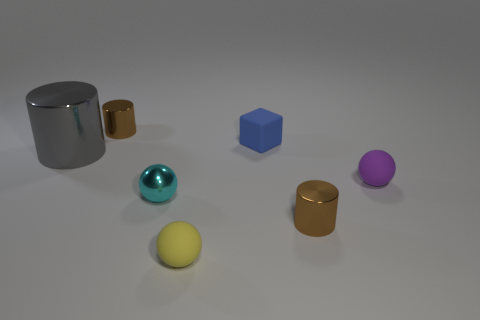There is another small matte object that is the same shape as the purple thing; what color is it? The object that shares the same spherical shape as the matte purple sphere is colored yellow. It exhibits a similar matte finish and size, which distinguishes it from the other objects in the scene that have more reflective surfaces or different shapes. 